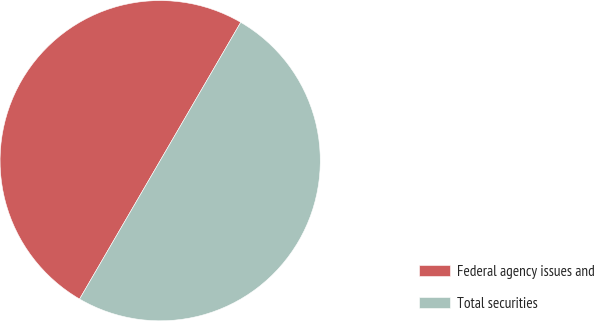Convert chart to OTSL. <chart><loc_0><loc_0><loc_500><loc_500><pie_chart><fcel>Federal agency issues and<fcel>Total securities<nl><fcel>50.0%<fcel>50.0%<nl></chart> 